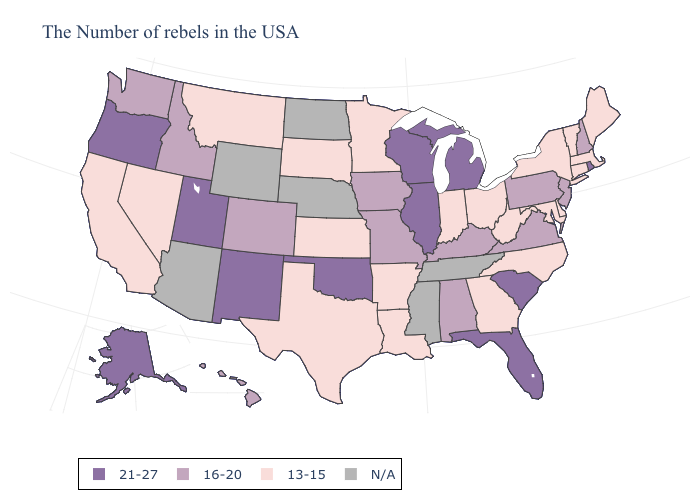Does Oregon have the highest value in the USA?
Concise answer only. Yes. What is the value of Illinois?
Quick response, please. 21-27. What is the lowest value in states that border Tennessee?
Quick response, please. 13-15. Which states have the highest value in the USA?
Short answer required. Rhode Island, South Carolina, Florida, Michigan, Wisconsin, Illinois, Oklahoma, New Mexico, Utah, Oregon, Alaska. Does Texas have the highest value in the USA?
Be succinct. No. Does Wisconsin have the lowest value in the MidWest?
Short answer required. No. Name the states that have a value in the range 13-15?
Give a very brief answer. Maine, Massachusetts, Vermont, Connecticut, New York, Delaware, Maryland, North Carolina, West Virginia, Ohio, Georgia, Indiana, Louisiana, Arkansas, Minnesota, Kansas, Texas, South Dakota, Montana, Nevada, California. Does Colorado have the highest value in the USA?
Answer briefly. No. What is the highest value in the USA?
Keep it brief. 21-27. Name the states that have a value in the range 16-20?
Quick response, please. New Hampshire, New Jersey, Pennsylvania, Virginia, Kentucky, Alabama, Missouri, Iowa, Colorado, Idaho, Washington, Hawaii. Is the legend a continuous bar?
Answer briefly. No. Which states have the lowest value in the USA?
Write a very short answer. Maine, Massachusetts, Vermont, Connecticut, New York, Delaware, Maryland, North Carolina, West Virginia, Ohio, Georgia, Indiana, Louisiana, Arkansas, Minnesota, Kansas, Texas, South Dakota, Montana, Nevada, California. What is the value of Georgia?
Concise answer only. 13-15. Which states hav the highest value in the West?
Concise answer only. New Mexico, Utah, Oregon, Alaska. Name the states that have a value in the range N/A?
Be succinct. Tennessee, Mississippi, Nebraska, North Dakota, Wyoming, Arizona. 